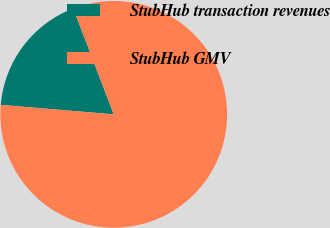<chart> <loc_0><loc_0><loc_500><loc_500><pie_chart><fcel>StubHub transaction revenues<fcel>StubHub GMV<nl><fcel>17.86%<fcel>82.14%<nl></chart> 